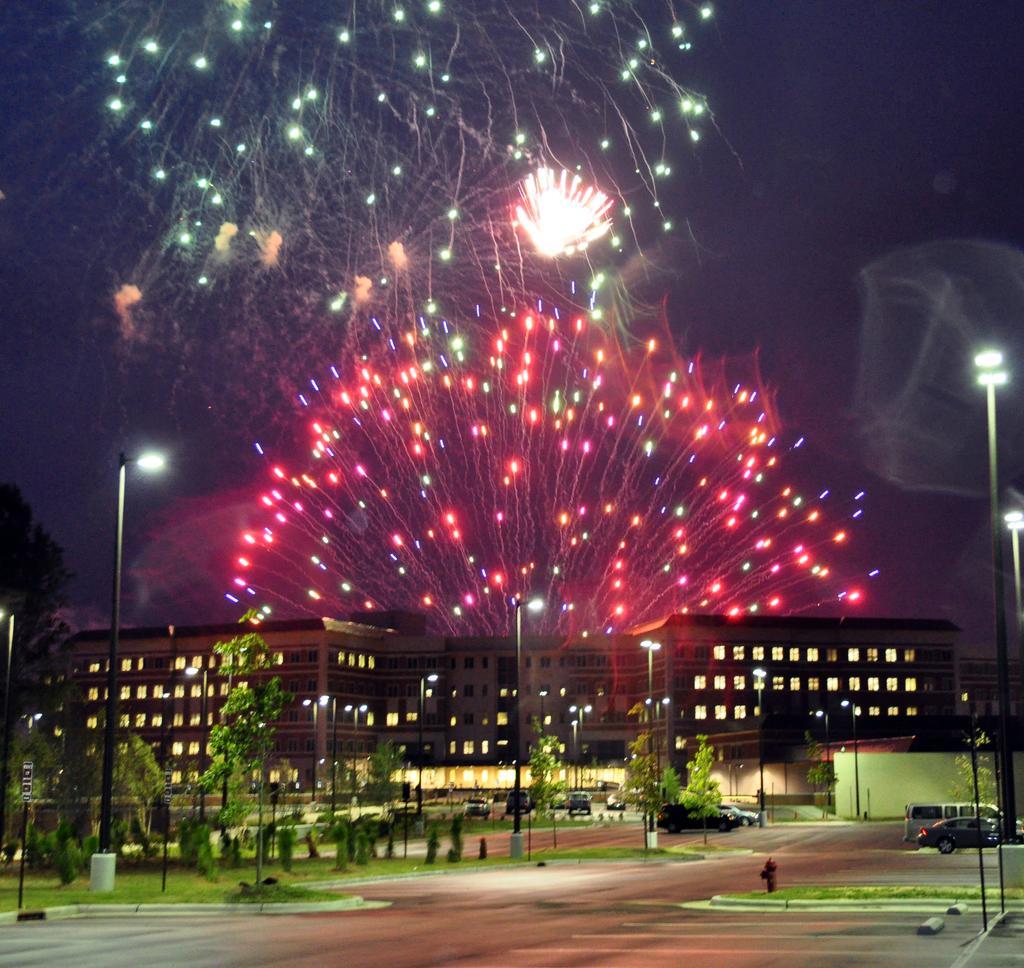How would you summarize this image in a sentence or two? This image consists of a building along with the light. At the bottom, there are trees, and cars parked on the road. At the top, we can see the crackers. On the left and right, there are poles along with lamps. 